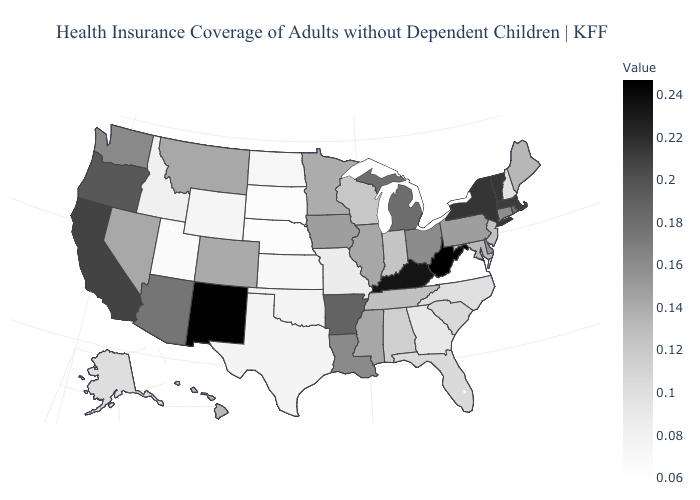Does New Hampshire have the lowest value in the Northeast?
Quick response, please. Yes. Does Connecticut have a lower value than Alaska?
Write a very short answer. No. 